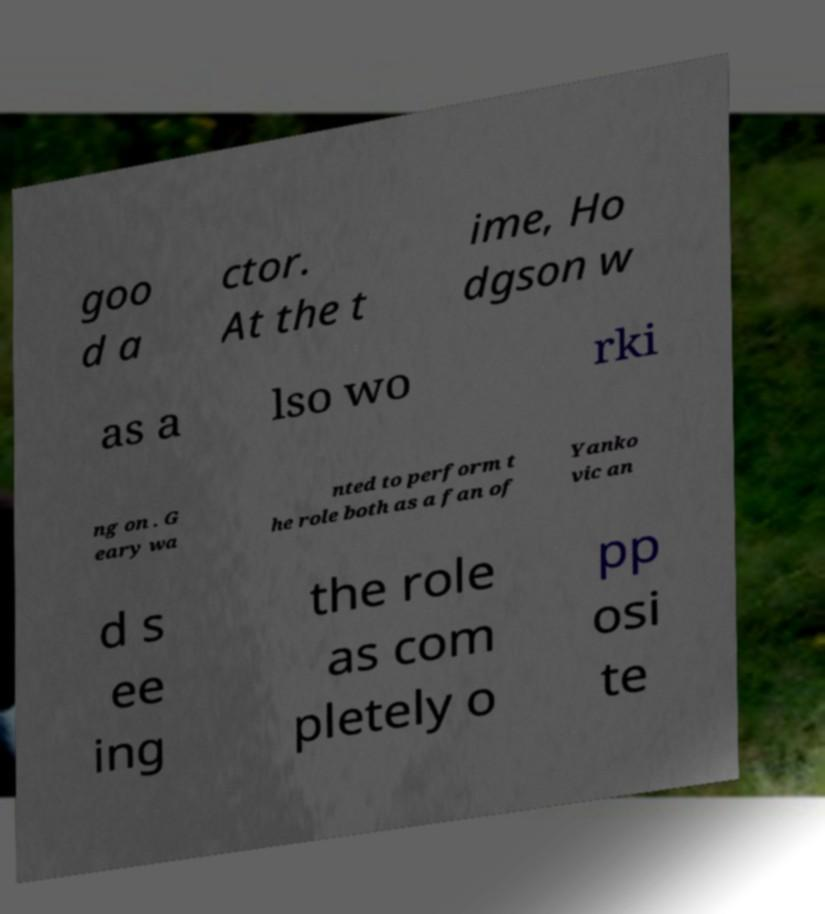There's text embedded in this image that I need extracted. Can you transcribe it verbatim? goo d a ctor. At the t ime, Ho dgson w as a lso wo rki ng on . G eary wa nted to perform t he role both as a fan of Yanko vic an d s ee ing the role as com pletely o pp osi te 